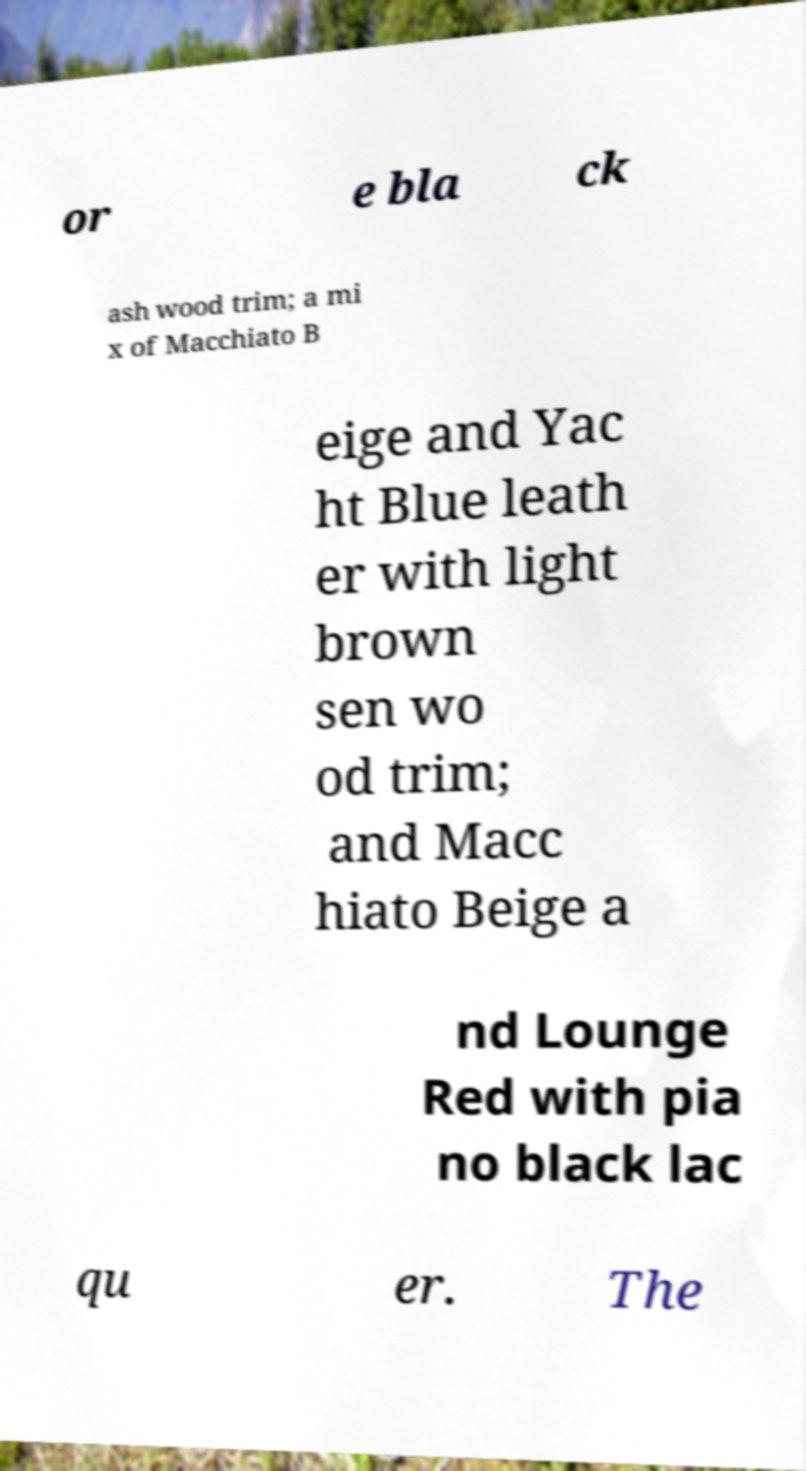Can you accurately transcribe the text from the provided image for me? or e bla ck ash wood trim; a mi x of Macchiato B eige and Yac ht Blue leath er with light brown sen wo od trim; and Macc hiato Beige a nd Lounge Red with pia no black lac qu er. The 